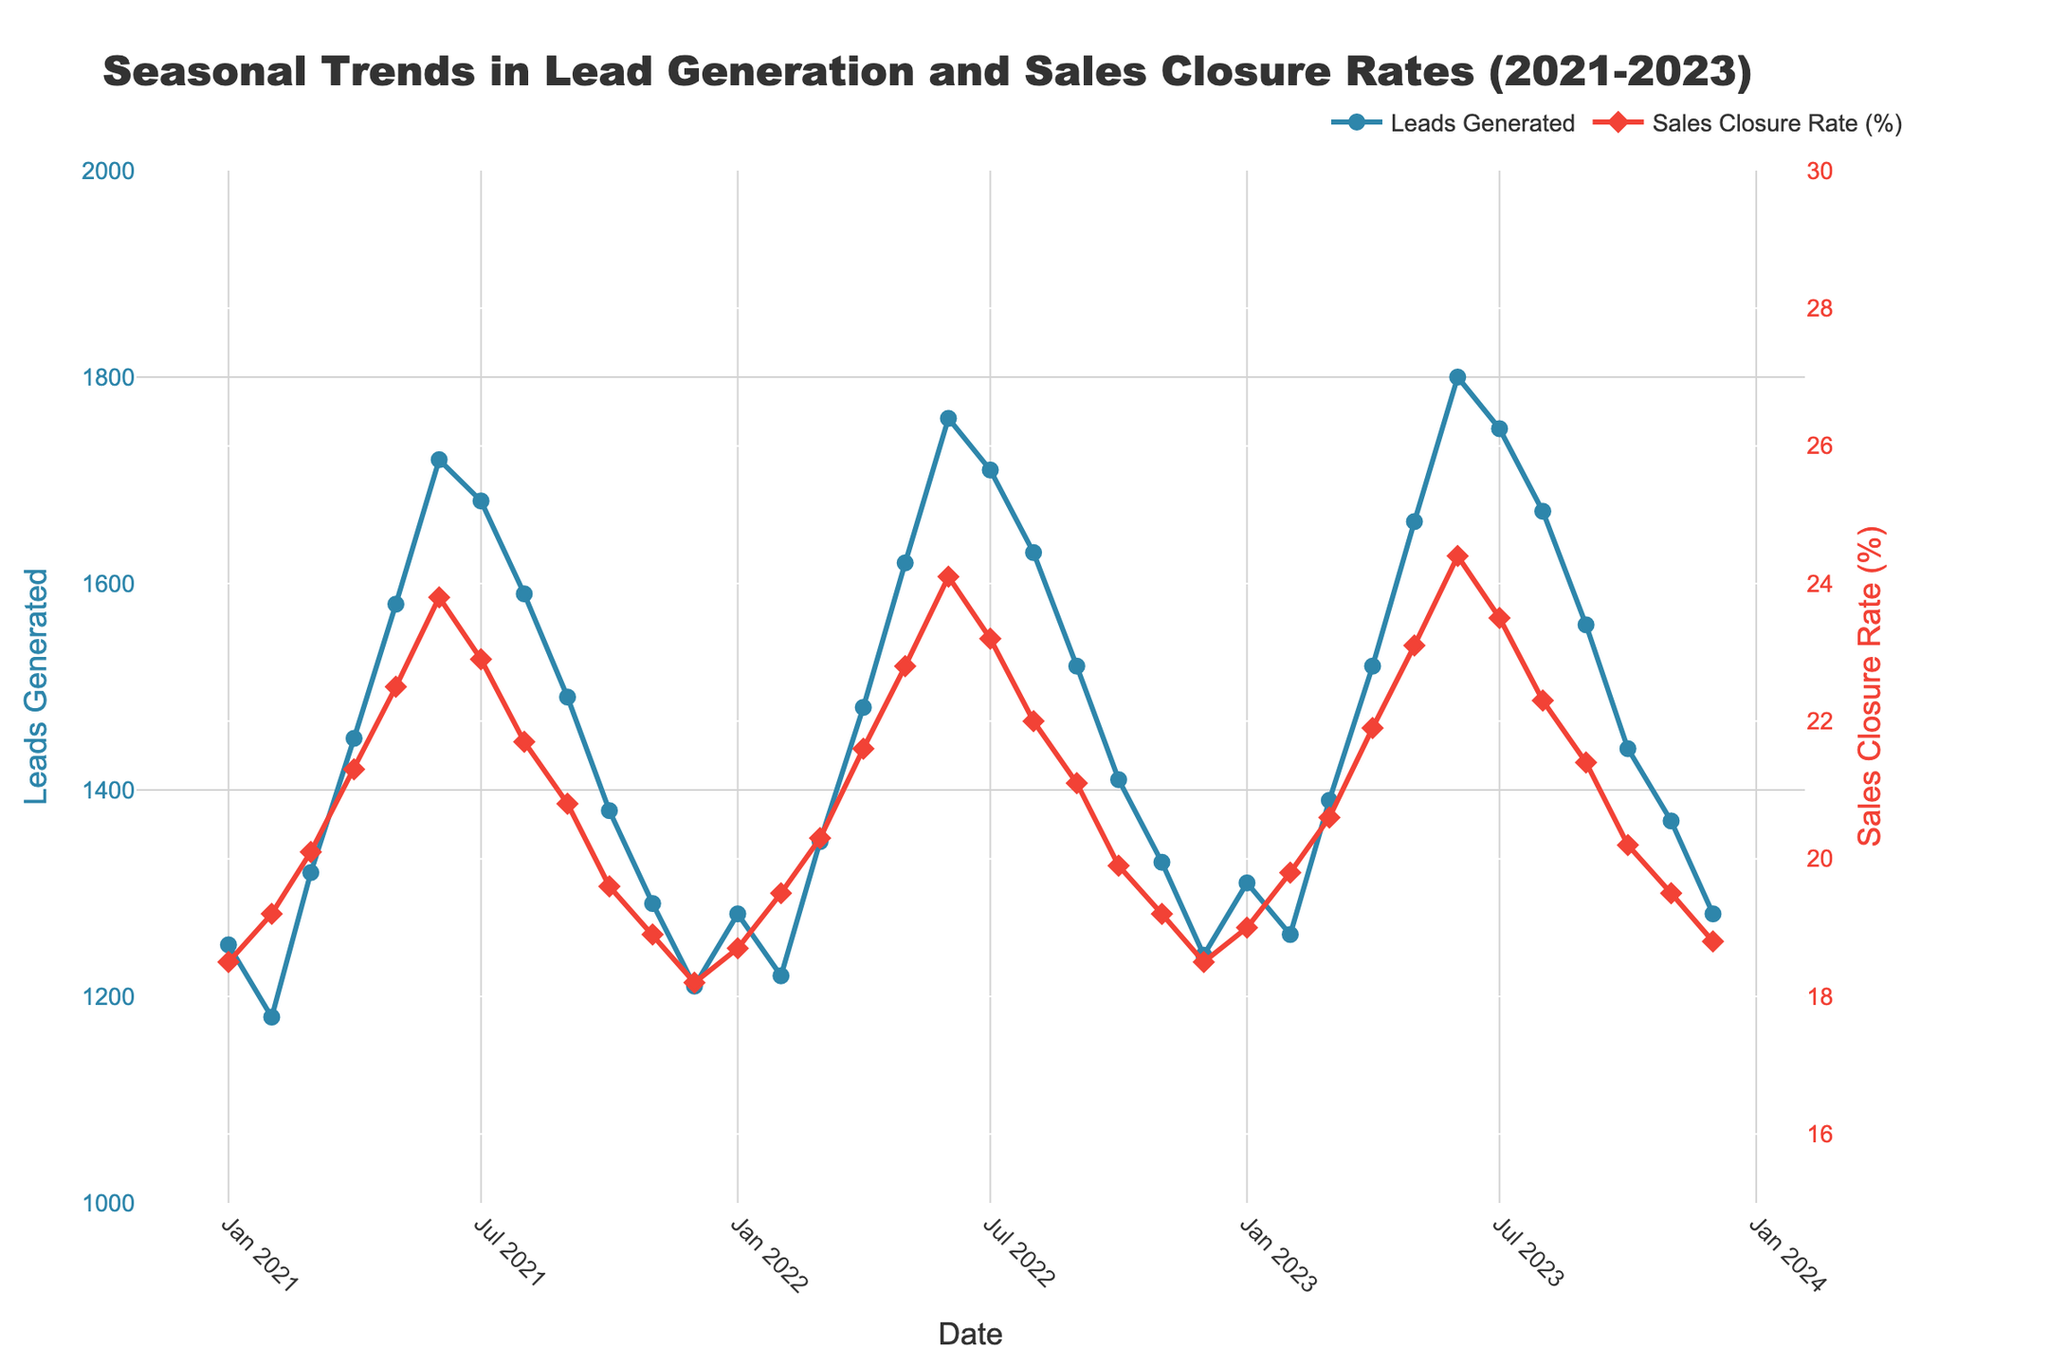What is the trend in the number of leads generated from January to December for each year? To identify the trend, examine the plot for each year from January to December. Generally, leads generated increase from January to June and then start declining till December for each year from 2021 to 2023.
Answer: Increase then decrease During which month was the highest sales closure rate observed and in which year? Look for the peak points of the red line (Sales Closure Rate) in the plot. The highest sales closure rate was observed in June 2023.
Answer: June 2023 What is the difference between the number of leads generated in June 2023 and December 2021? Find the data points for Leads Generated in June 2023 and December 2021. In June 2023, there were 1800 leads, and in December 2021, there were 1210 leads. Calculate the difference: 1800 - 1210 = 590.
Answer: 590 How did the sales closure rate in December 2022 compare to December 2023? Compare the two points on the red line (Sales Closure Rate) for December 2022 and December 2023. In December 2022, the rate was 18.5%, and in December 2023, it was 18.8%. Hence, it increased slightly.
Answer: Increased slightly What is the average sales closure rate for the April month across all three years? Extract the sales closure rates for April 2021, April 2022, and April 2023. They are 21.3%, 21.6%, and 21.9%, respectively. Calculate the average: (21.3 + 21.6 + 21.9) / 3 = 21.6%.
Answer: 21.6% Which year had the highest variability in leads generated within the year? Measure the variability by comparing the range (difference between maximum and minimum values) of leads generated for each year. In 2023, the leads generated range from 1260 (February) to 1800 (June) which is a difference of 540, higher than the ranges for 2021 and 2022.
Answer: 2023 Is there any season where both leads generation and sales closure rates are at their peak? Identify the overlapping peaks by examining both the blue and red lines. June is observed where both leads generated are at high levels and sales closure rates are at their peak across all three years.
Answer: June When did leads generation start dropping sharply after the mid-year? Look at the blue line immediately after June for each year to find when noticeable declines start. Significant drops begin in July each year.
Answer: July How does the August 2023 leads generation compare with August 2022? Compare the two points on the blue line for August 2023 and August 2022. In August 2023, leads generated were 1670, and in August 2022, they were 1630. It increased slightly.
Answer: Increased slightly What is the combined difference in sales closure rates between the highest and lowest months for each year? For each year, find the highest and lowest sales closure rates. Calculate the differences and then sum them. For 2021: Highest 23.8% (June) - Lowest 18.2% (December) = 5.6%. For 2022: Highest 24.1% (June) - Lowest 18.5% (December) = 5.6%. For 2023: Highest 24.4% (June) - Lowest 18.8% (December) = 5.6%. Now sum them: 5.6 + 5.6 + 5.6 = 16.8%.
Answer: 16.8% 